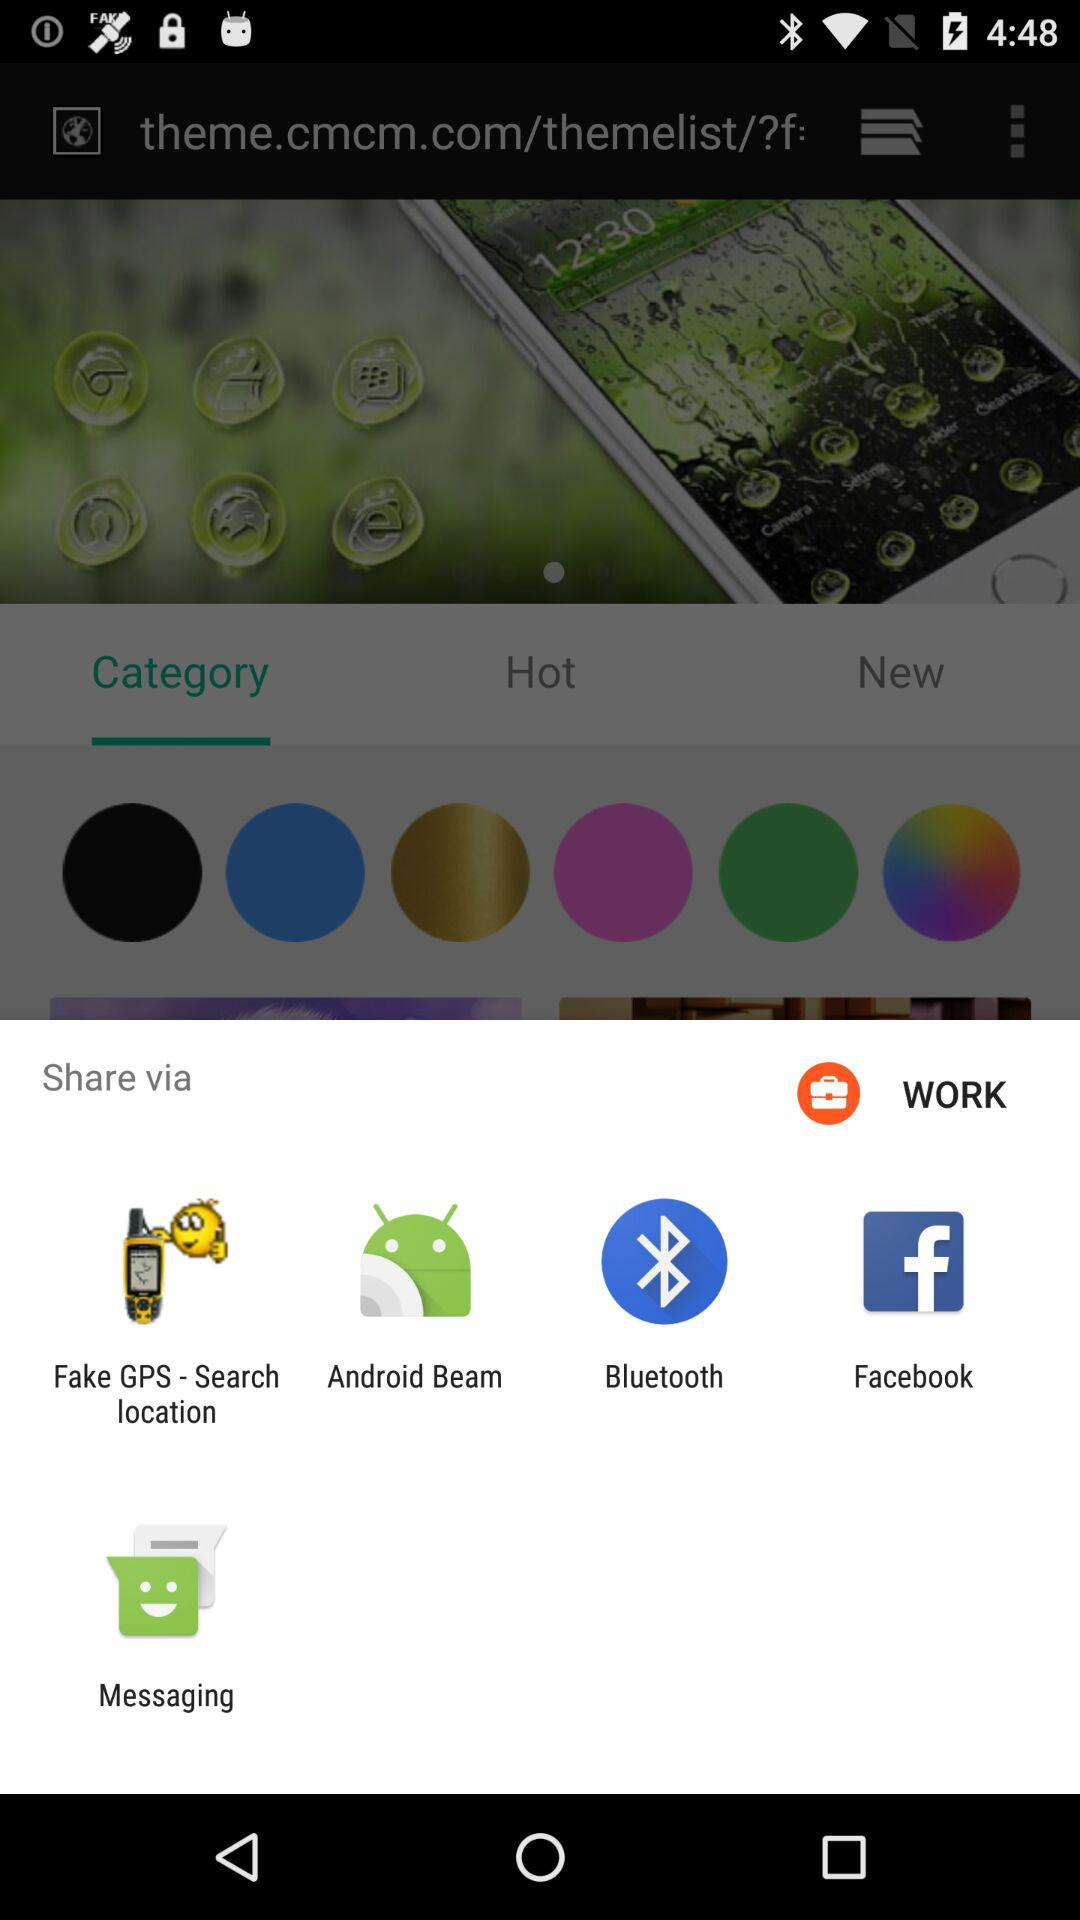Which applications can be used to share? The applications that can be used to share are "Fake GPS - Search location", "Android Beam", "Bluetooth", "Facebook" and "Messaging". 